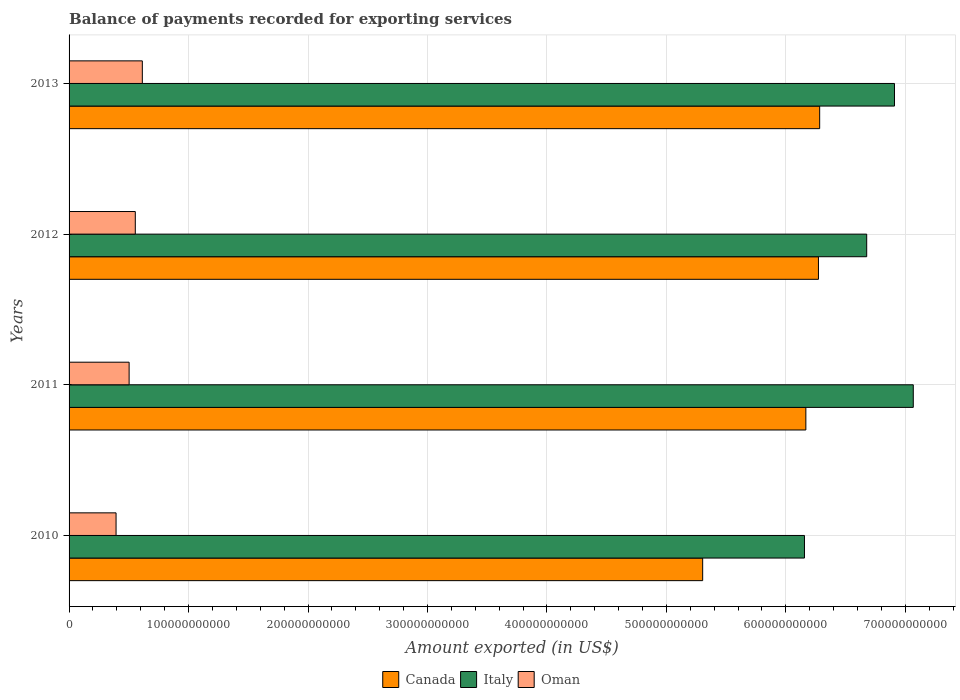How many different coloured bars are there?
Your answer should be very brief. 3. How many groups of bars are there?
Make the answer very short. 4. Are the number of bars per tick equal to the number of legend labels?
Your answer should be very brief. Yes. What is the label of the 3rd group of bars from the top?
Your response must be concise. 2011. What is the amount exported in Italy in 2012?
Keep it short and to the point. 6.68e+11. Across all years, what is the maximum amount exported in Canada?
Provide a succinct answer. 6.28e+11. Across all years, what is the minimum amount exported in Italy?
Your answer should be compact. 6.16e+11. In which year was the amount exported in Canada maximum?
Make the answer very short. 2013. In which year was the amount exported in Italy minimum?
Give a very brief answer. 2010. What is the total amount exported in Oman in the graph?
Give a very brief answer. 2.06e+11. What is the difference between the amount exported in Canada in 2011 and that in 2012?
Ensure brevity in your answer.  -1.05e+1. What is the difference between the amount exported in Italy in 2011 and the amount exported in Canada in 2012?
Your response must be concise. 7.94e+1. What is the average amount exported in Italy per year?
Provide a succinct answer. 6.70e+11. In the year 2011, what is the difference between the amount exported in Canada and amount exported in Oman?
Your answer should be compact. 5.66e+11. In how many years, is the amount exported in Canada greater than 580000000000 US$?
Provide a short and direct response. 3. What is the ratio of the amount exported in Canada in 2010 to that in 2011?
Ensure brevity in your answer.  0.86. Is the amount exported in Oman in 2010 less than that in 2011?
Your response must be concise. Yes. Is the difference between the amount exported in Canada in 2010 and 2012 greater than the difference between the amount exported in Oman in 2010 and 2012?
Your answer should be very brief. No. What is the difference between the highest and the second highest amount exported in Canada?
Your answer should be very brief. 1.01e+09. What is the difference between the highest and the lowest amount exported in Canada?
Provide a short and direct response. 9.79e+1. What does the 2nd bar from the top in 2012 represents?
Provide a succinct answer. Italy. What does the 3rd bar from the bottom in 2010 represents?
Offer a very short reply. Oman. Is it the case that in every year, the sum of the amount exported in Italy and amount exported in Canada is greater than the amount exported in Oman?
Give a very brief answer. Yes. How many years are there in the graph?
Your response must be concise. 4. What is the difference between two consecutive major ticks on the X-axis?
Keep it short and to the point. 1.00e+11. Are the values on the major ticks of X-axis written in scientific E-notation?
Your answer should be very brief. No. How many legend labels are there?
Provide a short and direct response. 3. What is the title of the graph?
Provide a short and direct response. Balance of payments recorded for exporting services. What is the label or title of the X-axis?
Your response must be concise. Amount exported (in US$). What is the label or title of the Y-axis?
Your answer should be compact. Years. What is the Amount exported (in US$) of Canada in 2010?
Your answer should be compact. 5.30e+11. What is the Amount exported (in US$) of Italy in 2010?
Offer a terse response. 6.16e+11. What is the Amount exported (in US$) in Oman in 2010?
Ensure brevity in your answer.  3.93e+1. What is the Amount exported (in US$) of Canada in 2011?
Ensure brevity in your answer.  6.17e+11. What is the Amount exported (in US$) in Italy in 2011?
Make the answer very short. 7.07e+11. What is the Amount exported (in US$) of Oman in 2011?
Offer a very short reply. 5.03e+1. What is the Amount exported (in US$) of Canada in 2012?
Your answer should be very brief. 6.27e+11. What is the Amount exported (in US$) of Italy in 2012?
Offer a terse response. 6.68e+11. What is the Amount exported (in US$) of Oman in 2012?
Provide a short and direct response. 5.54e+1. What is the Amount exported (in US$) in Canada in 2013?
Your answer should be very brief. 6.28e+11. What is the Amount exported (in US$) in Italy in 2013?
Your response must be concise. 6.91e+11. What is the Amount exported (in US$) of Oman in 2013?
Your answer should be very brief. 6.13e+1. Across all years, what is the maximum Amount exported (in US$) of Canada?
Offer a very short reply. 6.28e+11. Across all years, what is the maximum Amount exported (in US$) of Italy?
Your response must be concise. 7.07e+11. Across all years, what is the maximum Amount exported (in US$) in Oman?
Provide a succinct answer. 6.13e+1. Across all years, what is the minimum Amount exported (in US$) in Canada?
Offer a very short reply. 5.30e+11. Across all years, what is the minimum Amount exported (in US$) of Italy?
Provide a short and direct response. 6.16e+11. Across all years, what is the minimum Amount exported (in US$) in Oman?
Your response must be concise. 3.93e+1. What is the total Amount exported (in US$) of Canada in the graph?
Provide a short and direct response. 2.40e+12. What is the total Amount exported (in US$) in Italy in the graph?
Your answer should be compact. 2.68e+12. What is the total Amount exported (in US$) in Oman in the graph?
Provide a short and direct response. 2.06e+11. What is the difference between the Amount exported (in US$) in Canada in 2010 and that in 2011?
Ensure brevity in your answer.  -8.64e+1. What is the difference between the Amount exported (in US$) in Italy in 2010 and that in 2011?
Offer a terse response. -9.11e+1. What is the difference between the Amount exported (in US$) in Oman in 2010 and that in 2011?
Your answer should be compact. -1.09e+1. What is the difference between the Amount exported (in US$) in Canada in 2010 and that in 2012?
Your answer should be compact. -9.69e+1. What is the difference between the Amount exported (in US$) in Italy in 2010 and that in 2012?
Offer a terse response. -5.21e+1. What is the difference between the Amount exported (in US$) of Oman in 2010 and that in 2012?
Ensure brevity in your answer.  -1.61e+1. What is the difference between the Amount exported (in US$) in Canada in 2010 and that in 2013?
Provide a succinct answer. -9.79e+1. What is the difference between the Amount exported (in US$) of Italy in 2010 and that in 2013?
Keep it short and to the point. -7.54e+1. What is the difference between the Amount exported (in US$) in Oman in 2010 and that in 2013?
Ensure brevity in your answer.  -2.20e+1. What is the difference between the Amount exported (in US$) of Canada in 2011 and that in 2012?
Provide a short and direct response. -1.05e+1. What is the difference between the Amount exported (in US$) of Italy in 2011 and that in 2012?
Offer a terse response. 3.90e+1. What is the difference between the Amount exported (in US$) of Oman in 2011 and that in 2012?
Offer a terse response. -5.17e+09. What is the difference between the Amount exported (in US$) in Canada in 2011 and that in 2013?
Your response must be concise. -1.16e+1. What is the difference between the Amount exported (in US$) of Italy in 2011 and that in 2013?
Your answer should be compact. 1.57e+1. What is the difference between the Amount exported (in US$) of Oman in 2011 and that in 2013?
Offer a very short reply. -1.11e+1. What is the difference between the Amount exported (in US$) of Canada in 2012 and that in 2013?
Your response must be concise. -1.01e+09. What is the difference between the Amount exported (in US$) in Italy in 2012 and that in 2013?
Your answer should be compact. -2.33e+1. What is the difference between the Amount exported (in US$) of Oman in 2012 and that in 2013?
Make the answer very short. -5.88e+09. What is the difference between the Amount exported (in US$) of Canada in 2010 and the Amount exported (in US$) of Italy in 2011?
Your answer should be compact. -1.76e+11. What is the difference between the Amount exported (in US$) of Canada in 2010 and the Amount exported (in US$) of Oman in 2011?
Offer a terse response. 4.80e+11. What is the difference between the Amount exported (in US$) of Italy in 2010 and the Amount exported (in US$) of Oman in 2011?
Offer a very short reply. 5.65e+11. What is the difference between the Amount exported (in US$) of Canada in 2010 and the Amount exported (in US$) of Italy in 2012?
Provide a short and direct response. -1.37e+11. What is the difference between the Amount exported (in US$) of Canada in 2010 and the Amount exported (in US$) of Oman in 2012?
Keep it short and to the point. 4.75e+11. What is the difference between the Amount exported (in US$) of Italy in 2010 and the Amount exported (in US$) of Oman in 2012?
Provide a short and direct response. 5.60e+11. What is the difference between the Amount exported (in US$) of Canada in 2010 and the Amount exported (in US$) of Italy in 2013?
Your answer should be compact. -1.61e+11. What is the difference between the Amount exported (in US$) of Canada in 2010 and the Amount exported (in US$) of Oman in 2013?
Provide a short and direct response. 4.69e+11. What is the difference between the Amount exported (in US$) in Italy in 2010 and the Amount exported (in US$) in Oman in 2013?
Make the answer very short. 5.54e+11. What is the difference between the Amount exported (in US$) of Canada in 2011 and the Amount exported (in US$) of Italy in 2012?
Offer a terse response. -5.09e+1. What is the difference between the Amount exported (in US$) of Canada in 2011 and the Amount exported (in US$) of Oman in 2012?
Your answer should be very brief. 5.61e+11. What is the difference between the Amount exported (in US$) of Italy in 2011 and the Amount exported (in US$) of Oman in 2012?
Offer a very short reply. 6.51e+11. What is the difference between the Amount exported (in US$) in Canada in 2011 and the Amount exported (in US$) in Italy in 2013?
Provide a short and direct response. -7.42e+1. What is the difference between the Amount exported (in US$) in Canada in 2011 and the Amount exported (in US$) in Oman in 2013?
Make the answer very short. 5.55e+11. What is the difference between the Amount exported (in US$) of Italy in 2011 and the Amount exported (in US$) of Oman in 2013?
Give a very brief answer. 6.45e+11. What is the difference between the Amount exported (in US$) of Canada in 2012 and the Amount exported (in US$) of Italy in 2013?
Provide a succinct answer. -6.36e+1. What is the difference between the Amount exported (in US$) in Canada in 2012 and the Amount exported (in US$) in Oman in 2013?
Offer a very short reply. 5.66e+11. What is the difference between the Amount exported (in US$) of Italy in 2012 and the Amount exported (in US$) of Oman in 2013?
Keep it short and to the point. 6.06e+11. What is the average Amount exported (in US$) of Canada per year?
Make the answer very short. 6.01e+11. What is the average Amount exported (in US$) in Italy per year?
Your answer should be compact. 6.70e+11. What is the average Amount exported (in US$) in Oman per year?
Your response must be concise. 5.16e+1. In the year 2010, what is the difference between the Amount exported (in US$) of Canada and Amount exported (in US$) of Italy?
Your answer should be very brief. -8.52e+1. In the year 2010, what is the difference between the Amount exported (in US$) in Canada and Amount exported (in US$) in Oman?
Make the answer very short. 4.91e+11. In the year 2010, what is the difference between the Amount exported (in US$) in Italy and Amount exported (in US$) in Oman?
Provide a succinct answer. 5.76e+11. In the year 2011, what is the difference between the Amount exported (in US$) of Canada and Amount exported (in US$) of Italy?
Make the answer very short. -8.99e+1. In the year 2011, what is the difference between the Amount exported (in US$) in Canada and Amount exported (in US$) in Oman?
Your answer should be very brief. 5.66e+11. In the year 2011, what is the difference between the Amount exported (in US$) in Italy and Amount exported (in US$) in Oman?
Keep it short and to the point. 6.56e+11. In the year 2012, what is the difference between the Amount exported (in US$) of Canada and Amount exported (in US$) of Italy?
Give a very brief answer. -4.04e+1. In the year 2012, what is the difference between the Amount exported (in US$) in Canada and Amount exported (in US$) in Oman?
Make the answer very short. 5.72e+11. In the year 2012, what is the difference between the Amount exported (in US$) of Italy and Amount exported (in US$) of Oman?
Give a very brief answer. 6.12e+11. In the year 2013, what is the difference between the Amount exported (in US$) of Canada and Amount exported (in US$) of Italy?
Keep it short and to the point. -6.26e+1. In the year 2013, what is the difference between the Amount exported (in US$) in Canada and Amount exported (in US$) in Oman?
Give a very brief answer. 5.67e+11. In the year 2013, what is the difference between the Amount exported (in US$) in Italy and Amount exported (in US$) in Oman?
Your answer should be very brief. 6.30e+11. What is the ratio of the Amount exported (in US$) in Canada in 2010 to that in 2011?
Offer a very short reply. 0.86. What is the ratio of the Amount exported (in US$) in Italy in 2010 to that in 2011?
Your answer should be very brief. 0.87. What is the ratio of the Amount exported (in US$) of Oman in 2010 to that in 2011?
Your answer should be compact. 0.78. What is the ratio of the Amount exported (in US$) in Canada in 2010 to that in 2012?
Ensure brevity in your answer.  0.85. What is the ratio of the Amount exported (in US$) in Italy in 2010 to that in 2012?
Offer a very short reply. 0.92. What is the ratio of the Amount exported (in US$) in Oman in 2010 to that in 2012?
Keep it short and to the point. 0.71. What is the ratio of the Amount exported (in US$) in Canada in 2010 to that in 2013?
Provide a succinct answer. 0.84. What is the ratio of the Amount exported (in US$) of Italy in 2010 to that in 2013?
Give a very brief answer. 0.89. What is the ratio of the Amount exported (in US$) in Oman in 2010 to that in 2013?
Make the answer very short. 0.64. What is the ratio of the Amount exported (in US$) of Canada in 2011 to that in 2012?
Provide a short and direct response. 0.98. What is the ratio of the Amount exported (in US$) in Italy in 2011 to that in 2012?
Your response must be concise. 1.06. What is the ratio of the Amount exported (in US$) in Oman in 2011 to that in 2012?
Keep it short and to the point. 0.91. What is the ratio of the Amount exported (in US$) of Canada in 2011 to that in 2013?
Ensure brevity in your answer.  0.98. What is the ratio of the Amount exported (in US$) in Italy in 2011 to that in 2013?
Make the answer very short. 1.02. What is the ratio of the Amount exported (in US$) in Oman in 2011 to that in 2013?
Keep it short and to the point. 0.82. What is the ratio of the Amount exported (in US$) in Italy in 2012 to that in 2013?
Offer a terse response. 0.97. What is the ratio of the Amount exported (in US$) in Oman in 2012 to that in 2013?
Ensure brevity in your answer.  0.9. What is the difference between the highest and the second highest Amount exported (in US$) of Canada?
Make the answer very short. 1.01e+09. What is the difference between the highest and the second highest Amount exported (in US$) of Italy?
Offer a very short reply. 1.57e+1. What is the difference between the highest and the second highest Amount exported (in US$) of Oman?
Provide a succinct answer. 5.88e+09. What is the difference between the highest and the lowest Amount exported (in US$) in Canada?
Offer a terse response. 9.79e+1. What is the difference between the highest and the lowest Amount exported (in US$) of Italy?
Your response must be concise. 9.11e+1. What is the difference between the highest and the lowest Amount exported (in US$) of Oman?
Offer a very short reply. 2.20e+1. 